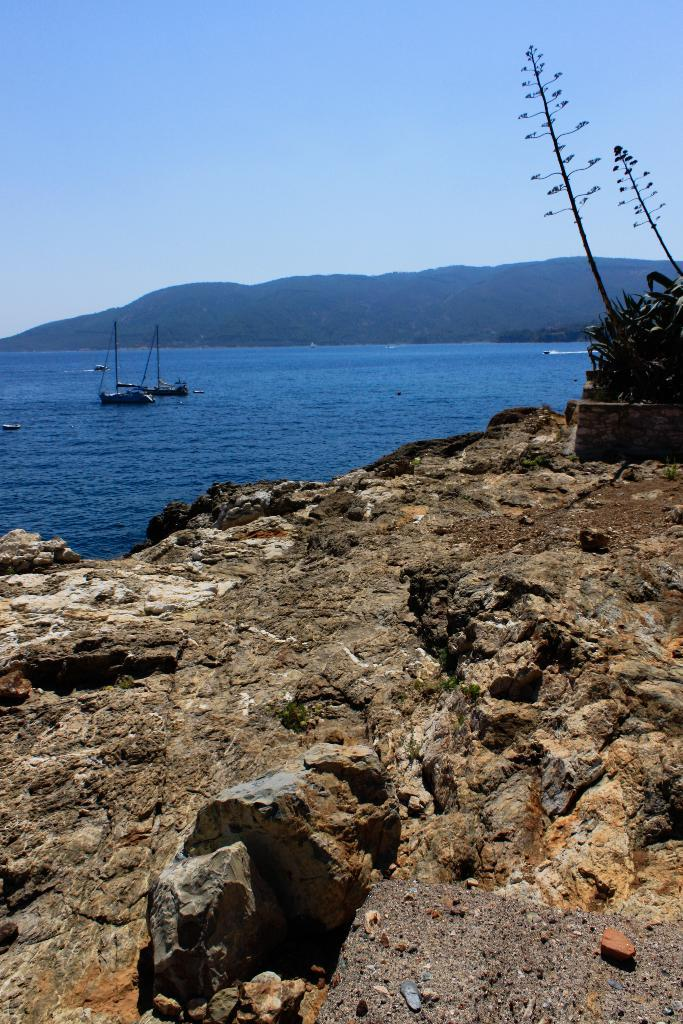What is located in the foreground of the image? There is a rock in the foreground of the image. What else can be seen in the foreground? There are plants on the right side of the foreground. What is visible in the background of the image? There are boats on water, a mountain, and the sky visible in the background. Can you describe the boats in the image? The boats are in the background of the image, and they are on water. What type of cloth is draped over the mountain in the image? There is no cloth draped over the mountain in the image; it is a natural landscape with a mountain and water. What kind of silk is visible on the rock in the foreground? There is no silk present on the rock in the foreground; it is a natural rock formation. 